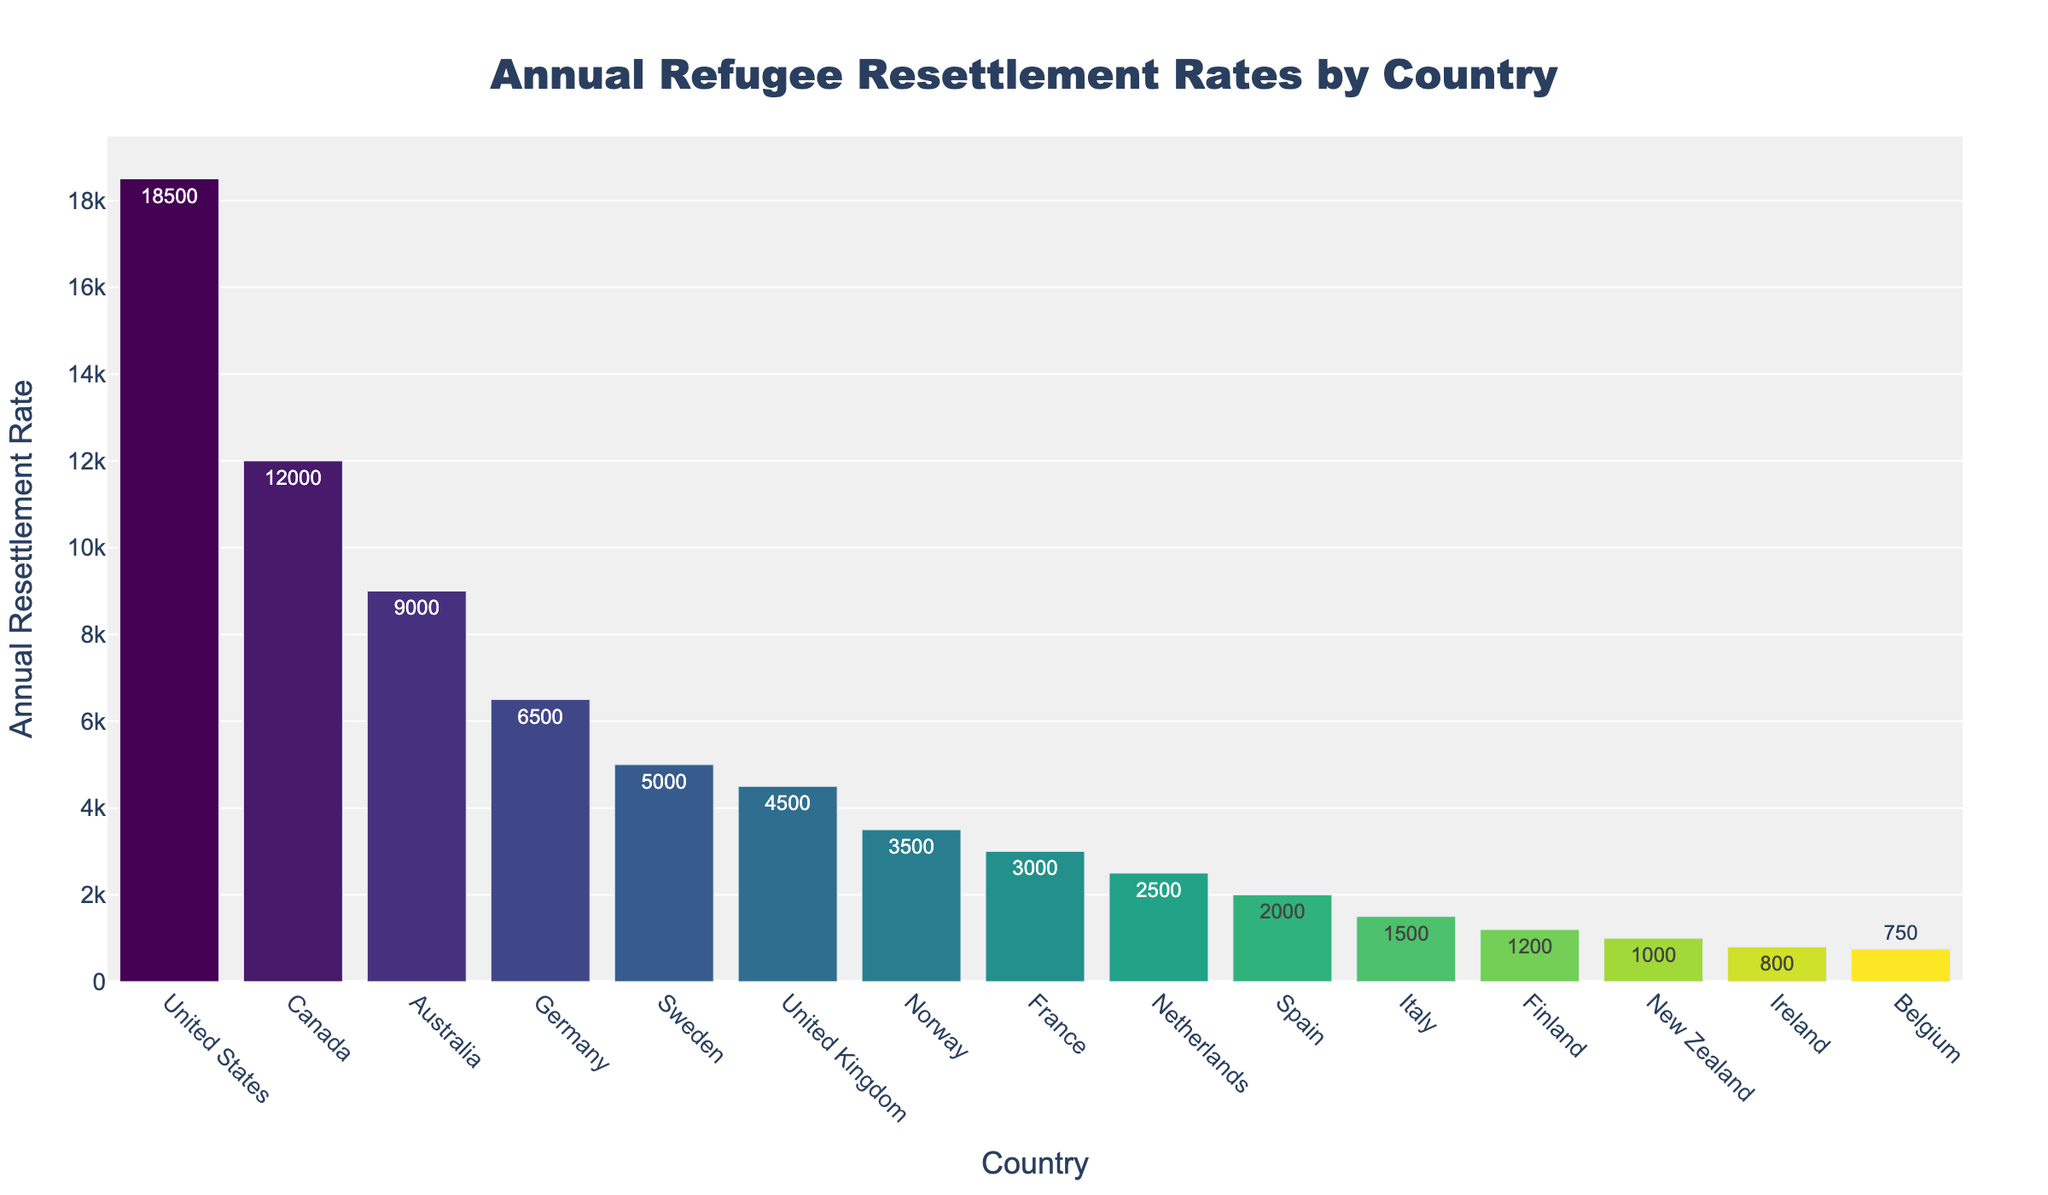what is the annual refugee resettlement rate in the leading country? Locate the bar representing the United States, the country with the highest bar height. The text on the bar indicates the value.
Answer: 18500 Which two countries have similar refugee resettlement rates? Look for bars with approximately the same height and compare their text values. Sweden and the United Kingdom have similar resettlement rates of 5000 and 4500, respectively.
Answer: Sweden and the United Kingdom What is the total annual resettlement rate for Germany and Sweden? Find and sum the values for Germany and Sweden. Germany has 6500 and Sweden has 5000. Adding them gives 6500 + 5000 = 11500.
Answer: 11500 Which country has the lowest annual refugee resettlement rate? Identify the shortest bar. The corresponding country is Belgium with a rate of 750.
Answer: Belgium How much higher is the US's resettlement rate than Finland's? Find the values for the US and Finland and calculate the difference. The US has 18500 and Finland has 1200. The difference is 18500 - 1200 = 17300.
Answer: 17300 Among the top five countries, what is the average annual refugee resettlement rate? Identify the top five countries by sorting the bars by height from high to low. The countries are the US, Canada, Australia, Germany, and Sweden. Sum their resettlement rates and divide by five: (18500 + 12000 + 9000 + 6500 + 5000) / 5 = 51500 / 5 = 10300.
Answer: 10300 Which country has a resettlement rate closer to the median of the listed countries? List the resettlement rates in sorted order to find the median. The sorted list is: 750, 800, 1000, 1200, 1500, 2000, 2500, 3000, 3500, 4500, 5000, 6500, 9000, 12000, 18500. The median is the value in the middle, which is 3000 (France).
Answer: France Which countries have a resettlement rate less than 3000? Identify the bars whose heights are below the 3000 mark. The corresponding countries are Spain, Italy, Finland, New Zealand, Ireland, and Belgium.
Answer: Spain, Italy, Finland, New Zealand, Ireland, and Belgium What is the combined resettlement rate for the countries with rates over 10000? Find countries with rates over 10000 and sum them. The US (18500) and Canada (12000). Adding them results in 18500 + 12000 = 30500.
Answer: 30500 